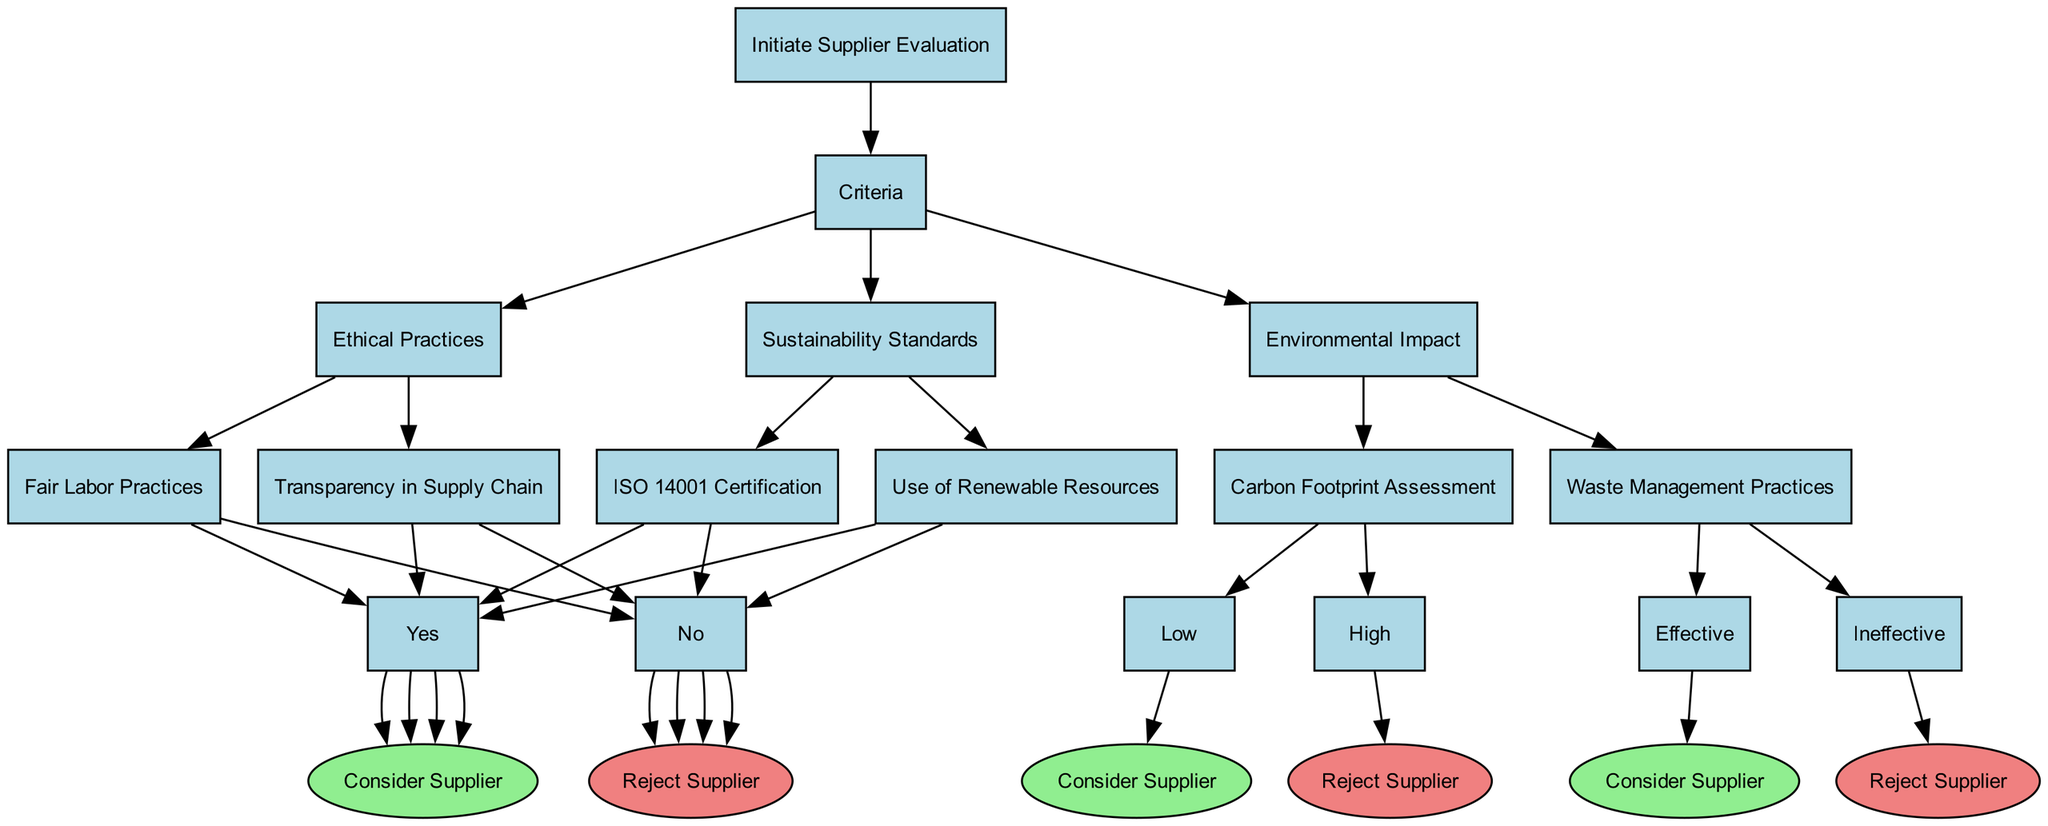What is the first step in the decision tree? The first step in the decision tree is to "Initiate Supplier Evaluation," which is the starting point of the decision-making process for selecting suppliers based on ethical practices and sustainability.
Answer: Initiate Supplier Evaluation How many criteria are used to evaluate suppliers? There are three criteria used to evaluate suppliers: "Sustainability Standards," "Ethical Practices," and "Environmental Impact," each representing a distinct area of consideration.
Answer: 3 What happens if a supplier does not have ISO 14001 Certification? If a supplier does not have ISO 14001 Certification, the decision tree indicates to "Reject Supplier," which is the outcome when this specific criterion is not met.
Answer: Reject Supplier What is the outcome if a supplier practices Fair Labor Practices and has Effective Waste Management Practices? If a supplier practices Fair Labor Practices (Yes) and has Effective Waste Management Practices (Effective), both criteria lead to considering the supplier, culminating in the outcome of "Consider Supplier."
Answer: Consider Supplier How many potential rejection outcomes are there in total? There are five rejection outcomes in total: "Reject Supplier" from each of the five conditions—ISO 14001 Certification, Use of Renewable Resources, Fair Labor Practices, Transparency in Supply Chain, and Environmental Impact assessments (High Carbon Footprint and Ineffective Waste Management).
Answer: 5 If a supplier has a Low Carbon Footprint, what must also be true for them to be considered? For a supplier to be considered with a Low Carbon Footprint, they must also meet at least one other criterion from the tree, meaning they must also adhere to either sustainability or ethical practices, all of which contribute to the final decision.
Answer: Must meet other criteria Does the decision tree allow for a supplier to be accepted with one criterion failure? No, a supplier cannot be accepted with one criterion failure as each criterion must be satisfied; the tree is designed such that all conditions within the selected criterion must be met for consideration.
Answer: No What signifies a 'Consider Supplier' outcome in the decision tree? A "Consider Supplier" outcome is signified when any of the criteria for Sustainability Standards, Ethical Practices, or Environmental Impact are met favorably, leading to favorable decision points in the flow of the tree.
Answer: Yes (to criteria) 